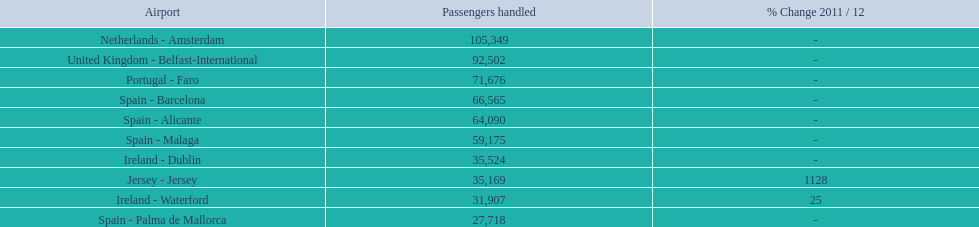Considering the top 10 busiest routes to and from london southend airport, what is the average volume of passengers processed? 58,967.5. Parse the table in full. {'header': ['Airport', 'Passengers handled', '% Change 2011 / 12'], 'rows': [['Netherlands - Amsterdam', '105,349', '-'], ['United Kingdom - Belfast-International', '92,502', '-'], ['Portugal - Faro', '71,676', '-'], ['Spain - Barcelona', '66,565', '-'], ['Spain - Alicante', '64,090', '-'], ['Spain - Malaga', '59,175', '-'], ['Ireland - Dublin', '35,524', '-'], ['Jersey - Jersey', '35,169', '1128'], ['Ireland - Waterford', '31,907', '25'], ['Spain - Palma de Mallorca', '27,718', '-']]} 